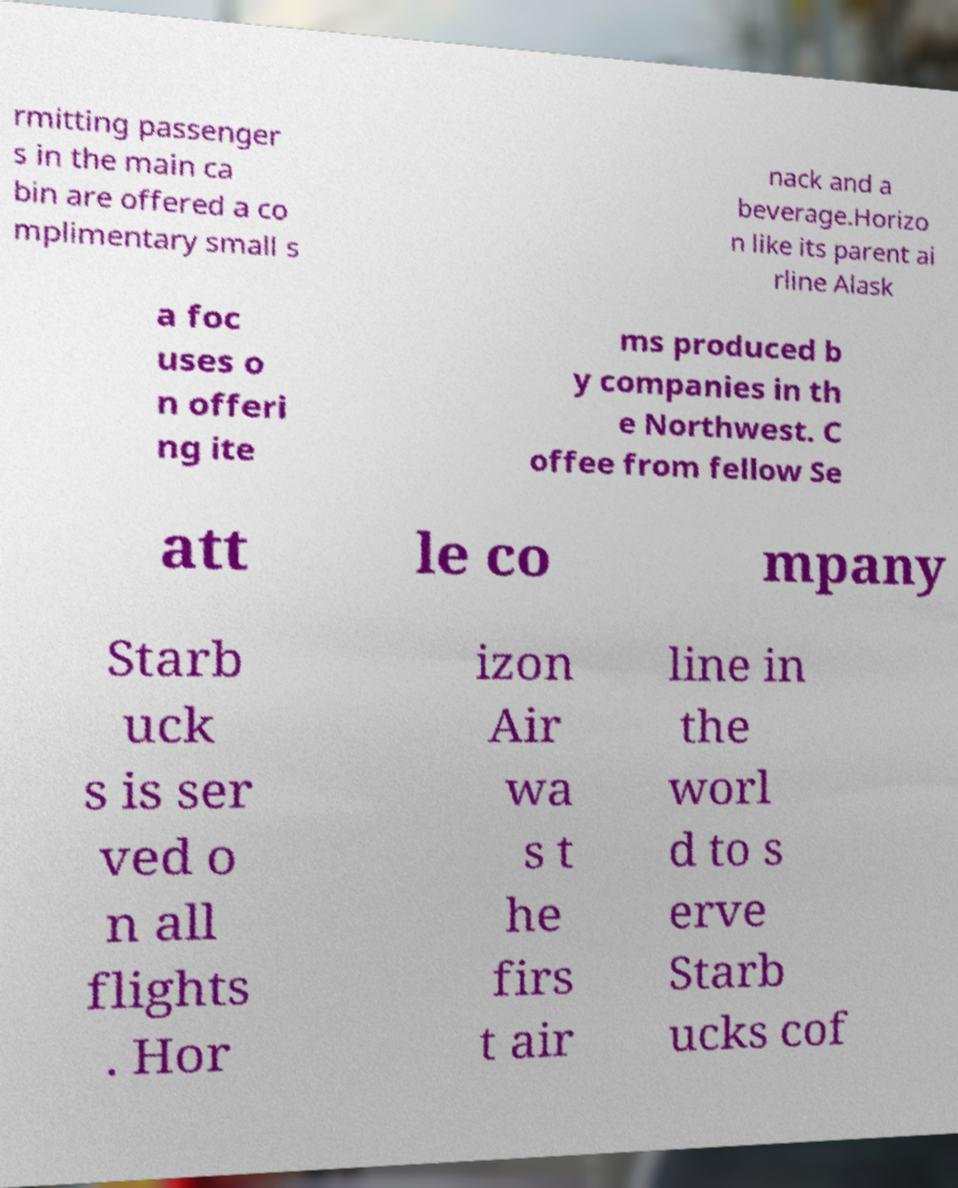Could you extract and type out the text from this image? rmitting passenger s in the main ca bin are offered a co mplimentary small s nack and a beverage.Horizo n like its parent ai rline Alask a foc uses o n offeri ng ite ms produced b y companies in th e Northwest. C offee from fellow Se att le co mpany Starb uck s is ser ved o n all flights . Hor izon Air wa s t he firs t air line in the worl d to s erve Starb ucks cof 